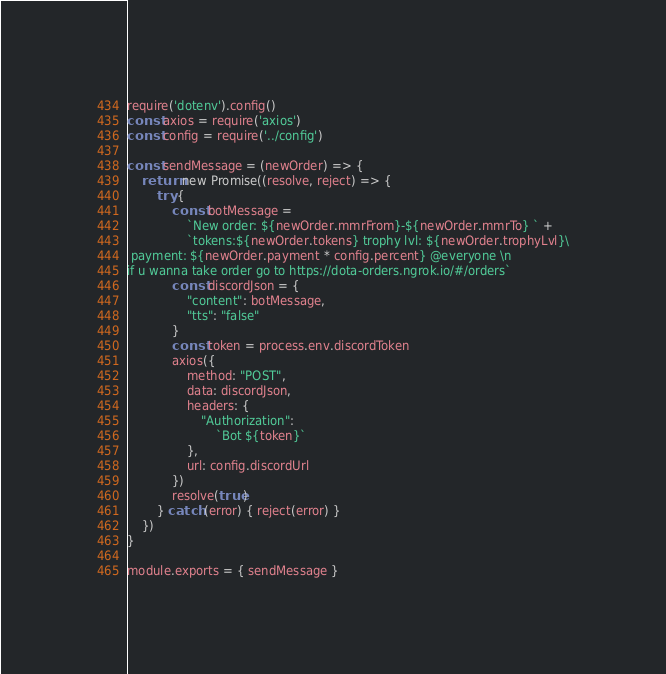Convert code to text. <code><loc_0><loc_0><loc_500><loc_500><_JavaScript_>require('dotenv').config()
const axios = require('axios')
const config = require('../config')

const sendMessage = (newOrder) => {
    return new Promise((resolve, reject) => {
        try {
            const botMessage =
                `New order: ${newOrder.mmrFrom}-${newOrder.mmrTo} ` +
                `tokens:${newOrder.tokens} trophy lvl: ${newOrder.trophyLvl}\
 payment: ${newOrder.payment * config.percent} @everyone \n
if u wanna take order go to https://dota-orders.ngrok.io/#/orders`
            const discordJson = {
                "content": botMessage,
                "tts": "false"
            }
            const token = process.env.discordToken
            axios({
                method: "POST",
                data: discordJson,
                headers: {
                    "Authorization":
                        `Bot ${token}`
                },
                url: config.discordUrl
            })
            resolve(true)
        } catch (error) { reject(error) }
    })
}

module.exports = { sendMessage }</code> 